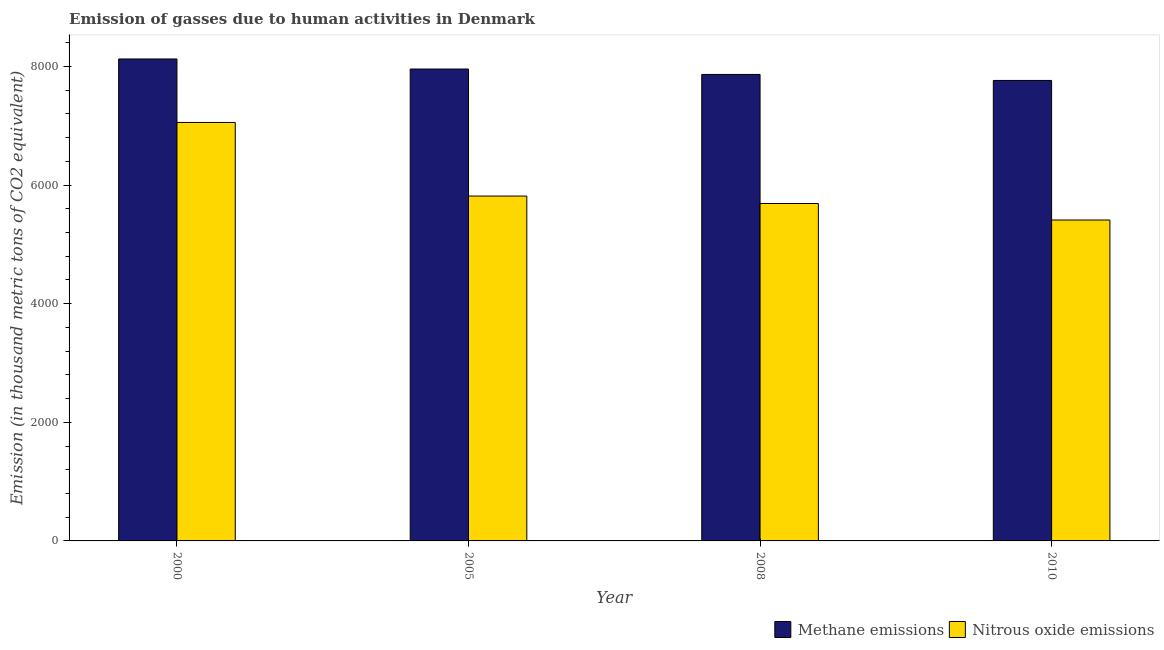Are the number of bars per tick equal to the number of legend labels?
Your answer should be very brief. Yes. What is the label of the 3rd group of bars from the left?
Your response must be concise. 2008. In how many cases, is the number of bars for a given year not equal to the number of legend labels?
Your response must be concise. 0. What is the amount of nitrous oxide emissions in 2008?
Keep it short and to the point. 5688.2. Across all years, what is the maximum amount of methane emissions?
Provide a succinct answer. 8124.9. Across all years, what is the minimum amount of methane emissions?
Your response must be concise. 7762.9. What is the total amount of nitrous oxide emissions in the graph?
Your answer should be very brief. 2.40e+04. What is the difference between the amount of nitrous oxide emissions in 2005 and that in 2008?
Make the answer very short. 125.7. What is the difference between the amount of methane emissions in 2005 and the amount of nitrous oxide emissions in 2008?
Offer a terse response. 91.4. What is the average amount of nitrous oxide emissions per year?
Make the answer very short. 5991.75. What is the ratio of the amount of nitrous oxide emissions in 2008 to that in 2010?
Give a very brief answer. 1.05. Is the difference between the amount of methane emissions in 2005 and 2010 greater than the difference between the amount of nitrous oxide emissions in 2005 and 2010?
Ensure brevity in your answer.  No. What is the difference between the highest and the second highest amount of methane emissions?
Your answer should be compact. 169.4. What is the difference between the highest and the lowest amount of methane emissions?
Give a very brief answer. 362. Is the sum of the amount of nitrous oxide emissions in 2000 and 2008 greater than the maximum amount of methane emissions across all years?
Provide a short and direct response. Yes. What does the 1st bar from the left in 2000 represents?
Provide a short and direct response. Methane emissions. What does the 1st bar from the right in 2008 represents?
Offer a very short reply. Nitrous oxide emissions. Are all the bars in the graph horizontal?
Your answer should be compact. No. Are the values on the major ticks of Y-axis written in scientific E-notation?
Keep it short and to the point. No. How many legend labels are there?
Provide a succinct answer. 2. How are the legend labels stacked?
Ensure brevity in your answer.  Horizontal. What is the title of the graph?
Provide a succinct answer. Emission of gasses due to human activities in Denmark. Does "Ages 15-24" appear as one of the legend labels in the graph?
Offer a terse response. No. What is the label or title of the Y-axis?
Your response must be concise. Emission (in thousand metric tons of CO2 equivalent). What is the Emission (in thousand metric tons of CO2 equivalent) in Methane emissions in 2000?
Provide a succinct answer. 8124.9. What is the Emission (in thousand metric tons of CO2 equivalent) of Nitrous oxide emissions in 2000?
Make the answer very short. 7054.9. What is the Emission (in thousand metric tons of CO2 equivalent) of Methane emissions in 2005?
Your answer should be compact. 7955.5. What is the Emission (in thousand metric tons of CO2 equivalent) of Nitrous oxide emissions in 2005?
Your response must be concise. 5813.9. What is the Emission (in thousand metric tons of CO2 equivalent) of Methane emissions in 2008?
Provide a succinct answer. 7864.1. What is the Emission (in thousand metric tons of CO2 equivalent) of Nitrous oxide emissions in 2008?
Make the answer very short. 5688.2. What is the Emission (in thousand metric tons of CO2 equivalent) in Methane emissions in 2010?
Provide a short and direct response. 7762.9. What is the Emission (in thousand metric tons of CO2 equivalent) of Nitrous oxide emissions in 2010?
Provide a succinct answer. 5410. Across all years, what is the maximum Emission (in thousand metric tons of CO2 equivalent) in Methane emissions?
Give a very brief answer. 8124.9. Across all years, what is the maximum Emission (in thousand metric tons of CO2 equivalent) of Nitrous oxide emissions?
Keep it short and to the point. 7054.9. Across all years, what is the minimum Emission (in thousand metric tons of CO2 equivalent) of Methane emissions?
Offer a terse response. 7762.9. Across all years, what is the minimum Emission (in thousand metric tons of CO2 equivalent) in Nitrous oxide emissions?
Give a very brief answer. 5410. What is the total Emission (in thousand metric tons of CO2 equivalent) in Methane emissions in the graph?
Give a very brief answer. 3.17e+04. What is the total Emission (in thousand metric tons of CO2 equivalent) of Nitrous oxide emissions in the graph?
Ensure brevity in your answer.  2.40e+04. What is the difference between the Emission (in thousand metric tons of CO2 equivalent) in Methane emissions in 2000 and that in 2005?
Provide a succinct answer. 169.4. What is the difference between the Emission (in thousand metric tons of CO2 equivalent) in Nitrous oxide emissions in 2000 and that in 2005?
Make the answer very short. 1241. What is the difference between the Emission (in thousand metric tons of CO2 equivalent) of Methane emissions in 2000 and that in 2008?
Offer a very short reply. 260.8. What is the difference between the Emission (in thousand metric tons of CO2 equivalent) of Nitrous oxide emissions in 2000 and that in 2008?
Offer a very short reply. 1366.7. What is the difference between the Emission (in thousand metric tons of CO2 equivalent) in Methane emissions in 2000 and that in 2010?
Offer a very short reply. 362. What is the difference between the Emission (in thousand metric tons of CO2 equivalent) in Nitrous oxide emissions in 2000 and that in 2010?
Provide a succinct answer. 1644.9. What is the difference between the Emission (in thousand metric tons of CO2 equivalent) in Methane emissions in 2005 and that in 2008?
Provide a succinct answer. 91.4. What is the difference between the Emission (in thousand metric tons of CO2 equivalent) of Nitrous oxide emissions in 2005 and that in 2008?
Give a very brief answer. 125.7. What is the difference between the Emission (in thousand metric tons of CO2 equivalent) in Methane emissions in 2005 and that in 2010?
Your answer should be very brief. 192.6. What is the difference between the Emission (in thousand metric tons of CO2 equivalent) in Nitrous oxide emissions in 2005 and that in 2010?
Give a very brief answer. 403.9. What is the difference between the Emission (in thousand metric tons of CO2 equivalent) in Methane emissions in 2008 and that in 2010?
Offer a terse response. 101.2. What is the difference between the Emission (in thousand metric tons of CO2 equivalent) of Nitrous oxide emissions in 2008 and that in 2010?
Your response must be concise. 278.2. What is the difference between the Emission (in thousand metric tons of CO2 equivalent) of Methane emissions in 2000 and the Emission (in thousand metric tons of CO2 equivalent) of Nitrous oxide emissions in 2005?
Your response must be concise. 2311. What is the difference between the Emission (in thousand metric tons of CO2 equivalent) of Methane emissions in 2000 and the Emission (in thousand metric tons of CO2 equivalent) of Nitrous oxide emissions in 2008?
Your answer should be very brief. 2436.7. What is the difference between the Emission (in thousand metric tons of CO2 equivalent) of Methane emissions in 2000 and the Emission (in thousand metric tons of CO2 equivalent) of Nitrous oxide emissions in 2010?
Offer a terse response. 2714.9. What is the difference between the Emission (in thousand metric tons of CO2 equivalent) of Methane emissions in 2005 and the Emission (in thousand metric tons of CO2 equivalent) of Nitrous oxide emissions in 2008?
Your answer should be very brief. 2267.3. What is the difference between the Emission (in thousand metric tons of CO2 equivalent) of Methane emissions in 2005 and the Emission (in thousand metric tons of CO2 equivalent) of Nitrous oxide emissions in 2010?
Keep it short and to the point. 2545.5. What is the difference between the Emission (in thousand metric tons of CO2 equivalent) of Methane emissions in 2008 and the Emission (in thousand metric tons of CO2 equivalent) of Nitrous oxide emissions in 2010?
Your answer should be compact. 2454.1. What is the average Emission (in thousand metric tons of CO2 equivalent) in Methane emissions per year?
Your answer should be compact. 7926.85. What is the average Emission (in thousand metric tons of CO2 equivalent) in Nitrous oxide emissions per year?
Your answer should be compact. 5991.75. In the year 2000, what is the difference between the Emission (in thousand metric tons of CO2 equivalent) in Methane emissions and Emission (in thousand metric tons of CO2 equivalent) in Nitrous oxide emissions?
Ensure brevity in your answer.  1070. In the year 2005, what is the difference between the Emission (in thousand metric tons of CO2 equivalent) of Methane emissions and Emission (in thousand metric tons of CO2 equivalent) of Nitrous oxide emissions?
Provide a succinct answer. 2141.6. In the year 2008, what is the difference between the Emission (in thousand metric tons of CO2 equivalent) of Methane emissions and Emission (in thousand metric tons of CO2 equivalent) of Nitrous oxide emissions?
Make the answer very short. 2175.9. In the year 2010, what is the difference between the Emission (in thousand metric tons of CO2 equivalent) of Methane emissions and Emission (in thousand metric tons of CO2 equivalent) of Nitrous oxide emissions?
Offer a very short reply. 2352.9. What is the ratio of the Emission (in thousand metric tons of CO2 equivalent) in Methane emissions in 2000 to that in 2005?
Your answer should be very brief. 1.02. What is the ratio of the Emission (in thousand metric tons of CO2 equivalent) in Nitrous oxide emissions in 2000 to that in 2005?
Give a very brief answer. 1.21. What is the ratio of the Emission (in thousand metric tons of CO2 equivalent) of Methane emissions in 2000 to that in 2008?
Offer a very short reply. 1.03. What is the ratio of the Emission (in thousand metric tons of CO2 equivalent) of Nitrous oxide emissions in 2000 to that in 2008?
Make the answer very short. 1.24. What is the ratio of the Emission (in thousand metric tons of CO2 equivalent) in Methane emissions in 2000 to that in 2010?
Offer a very short reply. 1.05. What is the ratio of the Emission (in thousand metric tons of CO2 equivalent) in Nitrous oxide emissions in 2000 to that in 2010?
Your response must be concise. 1.3. What is the ratio of the Emission (in thousand metric tons of CO2 equivalent) in Methane emissions in 2005 to that in 2008?
Keep it short and to the point. 1.01. What is the ratio of the Emission (in thousand metric tons of CO2 equivalent) in Nitrous oxide emissions in 2005 to that in 2008?
Offer a terse response. 1.02. What is the ratio of the Emission (in thousand metric tons of CO2 equivalent) in Methane emissions in 2005 to that in 2010?
Ensure brevity in your answer.  1.02. What is the ratio of the Emission (in thousand metric tons of CO2 equivalent) in Nitrous oxide emissions in 2005 to that in 2010?
Ensure brevity in your answer.  1.07. What is the ratio of the Emission (in thousand metric tons of CO2 equivalent) in Methane emissions in 2008 to that in 2010?
Offer a terse response. 1.01. What is the ratio of the Emission (in thousand metric tons of CO2 equivalent) in Nitrous oxide emissions in 2008 to that in 2010?
Offer a terse response. 1.05. What is the difference between the highest and the second highest Emission (in thousand metric tons of CO2 equivalent) of Methane emissions?
Make the answer very short. 169.4. What is the difference between the highest and the second highest Emission (in thousand metric tons of CO2 equivalent) in Nitrous oxide emissions?
Provide a succinct answer. 1241. What is the difference between the highest and the lowest Emission (in thousand metric tons of CO2 equivalent) of Methane emissions?
Give a very brief answer. 362. What is the difference between the highest and the lowest Emission (in thousand metric tons of CO2 equivalent) of Nitrous oxide emissions?
Provide a succinct answer. 1644.9. 